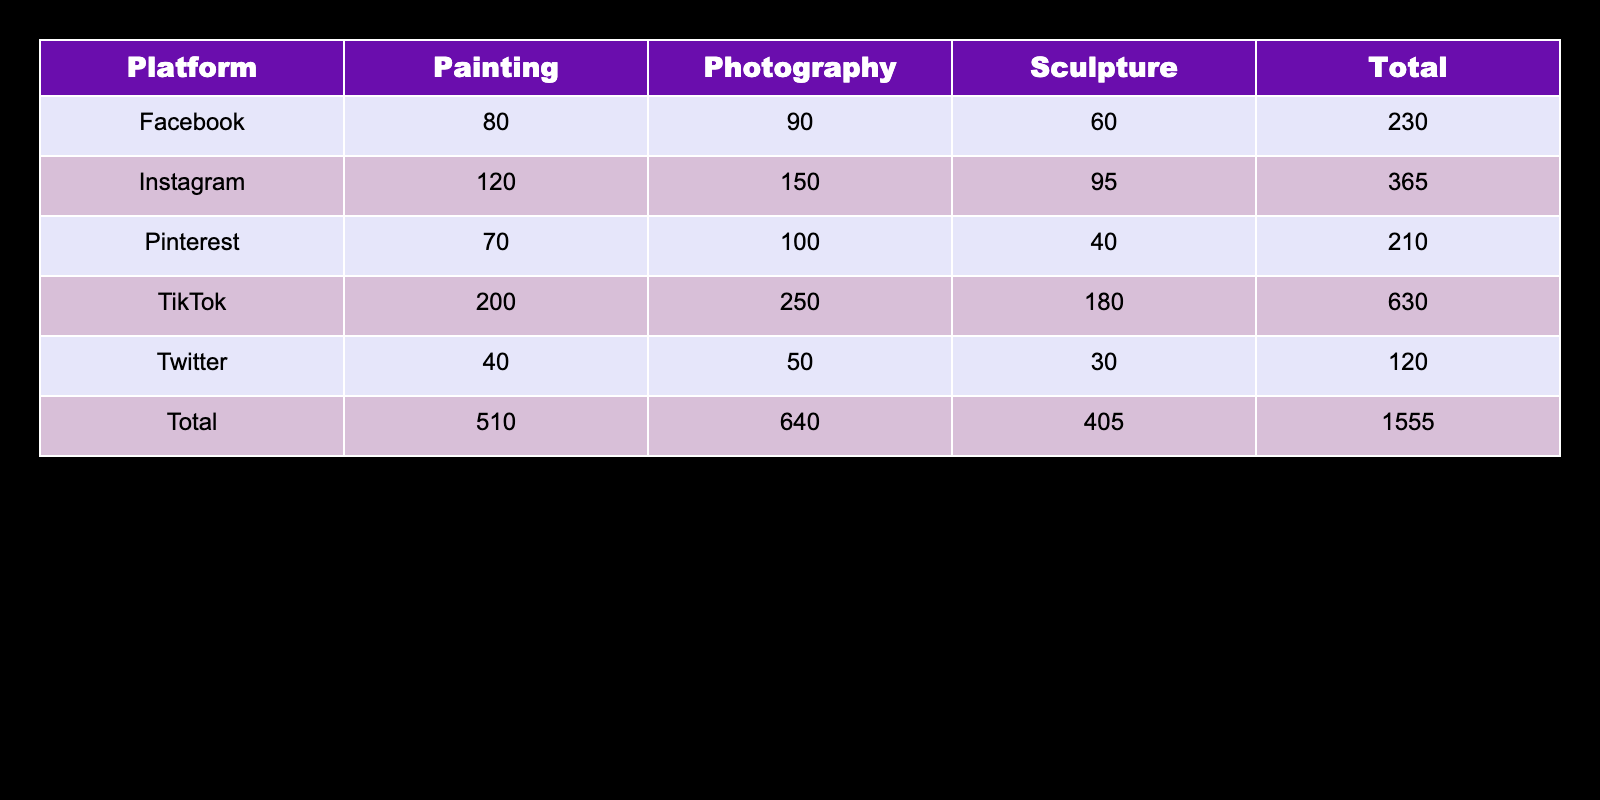What is the highest engagement frequency for TikTok? In the TikTok row, the engagement frequencies are 200 for Painting, 180 for Sculpture, and 250 for Photography. The highest value among these is 250 for Photography.
Answer: 250 Is Facebook the platform with the lowest engagement frequency for Sculpture? The engagement frequency for Sculpture on Facebook is 60. On Twitter, it’s 30. Since 30 is lower than 60, Facebook does not have the lowest frequency for Sculpture.
Answer: No What is the total engagement frequency for Photography across all platforms? To find the total for Photography, we sum up the frequencies: 150 (Instagram) + 90 (Facebook) + 50 (Twitter) + 250 (TikTok) + 100 (Pinterest) = 640.
Answer: 640 Which platform has the highest total engagement frequency? To determine the highest total, we calculate the totals for each platform: Instagram (120+95+150=365), Facebook (80+60+90=230), Twitter (40+30+50=120), TikTok (200+180+250=630), Pinterest (70+40+100=210). TikTok has the highest total of 630.
Answer: TikTok What is the average engagement frequency for Sculpture across all platforms? The frequencies for Sculpture are 95 (Instagram), 60 (Facebook), 30 (Twitter), 180 (TikTok), and 40 (Pinterest). We first sum these values: 95 + 60 + 30 + 180 + 40 = 405. There are 5 data points, so we calculate the average: 405/5 = 81.
Answer: 81 Is the engagement frequency for Painting higher on Instagram than on TikTok? The engagement frequency for Painting on Instagram is 120, while on TikTok it is 200. Since 120 is less than 200, Painting has a lower frequency on Instagram compared to TikTok.
Answer: No Which artwork type received the least engagement frequency on Twitter? The engagement frequencies for Twitter are 40 (Painting), 30 (Sculpture), and 50 (Photography). Sculpture has the lowest engagement frequency at 30.
Answer: Sculpture Calculate the difference in total engagement frequency between Instagram and Pinterest. The total for Instagram is 365 and for Pinterest is 210. The difference is 365 - 210 = 155.
Answer: 155 What is the total engagement frequency across all platforms for all artwork types? To find the grand total, we sum all the engagement frequencies: 120 + 95 + 150 + 80 + 60 + 90 + 40 + 30 + 50 + 200 + 180 + 250 + 70 + 40 + 100 = 1,545.
Answer: 1545 